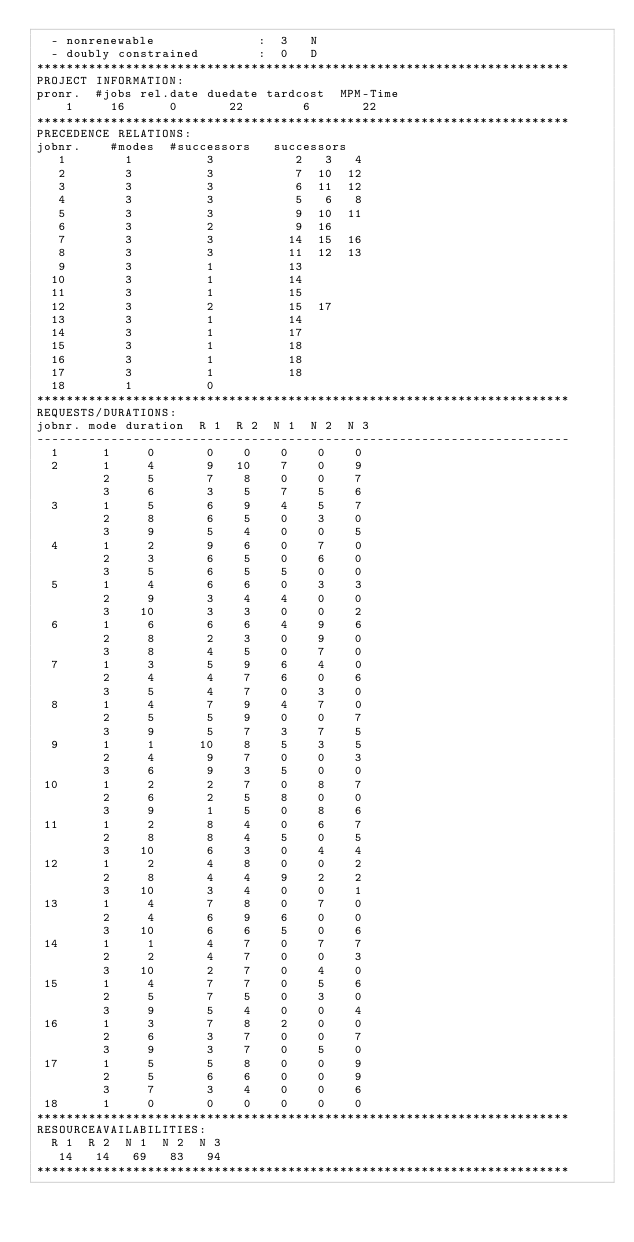<code> <loc_0><loc_0><loc_500><loc_500><_ObjectiveC_>  - nonrenewable              :  3   N
  - doubly constrained        :  0   D
************************************************************************
PROJECT INFORMATION:
pronr.  #jobs rel.date duedate tardcost  MPM-Time
    1     16      0       22        6       22
************************************************************************
PRECEDENCE RELATIONS:
jobnr.    #modes  #successors   successors
   1        1          3           2   3   4
   2        3          3           7  10  12
   3        3          3           6  11  12
   4        3          3           5   6   8
   5        3          3           9  10  11
   6        3          2           9  16
   7        3          3          14  15  16
   8        3          3          11  12  13
   9        3          1          13
  10        3          1          14
  11        3          1          15
  12        3          2          15  17
  13        3          1          14
  14        3          1          17
  15        3          1          18
  16        3          1          18
  17        3          1          18
  18        1          0        
************************************************************************
REQUESTS/DURATIONS:
jobnr. mode duration  R 1  R 2  N 1  N 2  N 3
------------------------------------------------------------------------
  1      1     0       0    0    0    0    0
  2      1     4       9   10    7    0    9
         2     5       7    8    0    0    7
         3     6       3    5    7    5    6
  3      1     5       6    9    4    5    7
         2     8       6    5    0    3    0
         3     9       5    4    0    0    5
  4      1     2       9    6    0    7    0
         2     3       6    5    0    6    0
         3     5       6    5    5    0    0
  5      1     4       6    6    0    3    3
         2     9       3    4    4    0    0
         3    10       3    3    0    0    2
  6      1     6       6    6    4    9    6
         2     8       2    3    0    9    0
         3     8       4    5    0    7    0
  7      1     3       5    9    6    4    0
         2     4       4    7    6    0    6
         3     5       4    7    0    3    0
  8      1     4       7    9    4    7    0
         2     5       5    9    0    0    7
         3     9       5    7    3    7    5
  9      1     1      10    8    5    3    5
         2     4       9    7    0    0    3
         3     6       9    3    5    0    0
 10      1     2       2    7    0    8    7
         2     6       2    5    8    0    0
         3     9       1    5    0    8    6
 11      1     2       8    4    0    6    7
         2     8       8    4    5    0    5
         3    10       6    3    0    4    4
 12      1     2       4    8    0    0    2
         2     8       4    4    9    2    2
         3    10       3    4    0    0    1
 13      1     4       7    8    0    7    0
         2     4       6    9    6    0    0
         3    10       6    6    5    0    6
 14      1     1       4    7    0    7    7
         2     2       4    7    0    0    3
         3    10       2    7    0    4    0
 15      1     4       7    7    0    5    6
         2     5       7    5    0    3    0
         3     9       5    4    0    0    4
 16      1     3       7    8    2    0    0
         2     6       3    7    0    0    7
         3     9       3    7    0    5    0
 17      1     5       5    8    0    0    9
         2     5       6    6    0    0    9
         3     7       3    4    0    0    6
 18      1     0       0    0    0    0    0
************************************************************************
RESOURCEAVAILABILITIES:
  R 1  R 2  N 1  N 2  N 3
   14   14   69   83   94
************************************************************************
</code> 